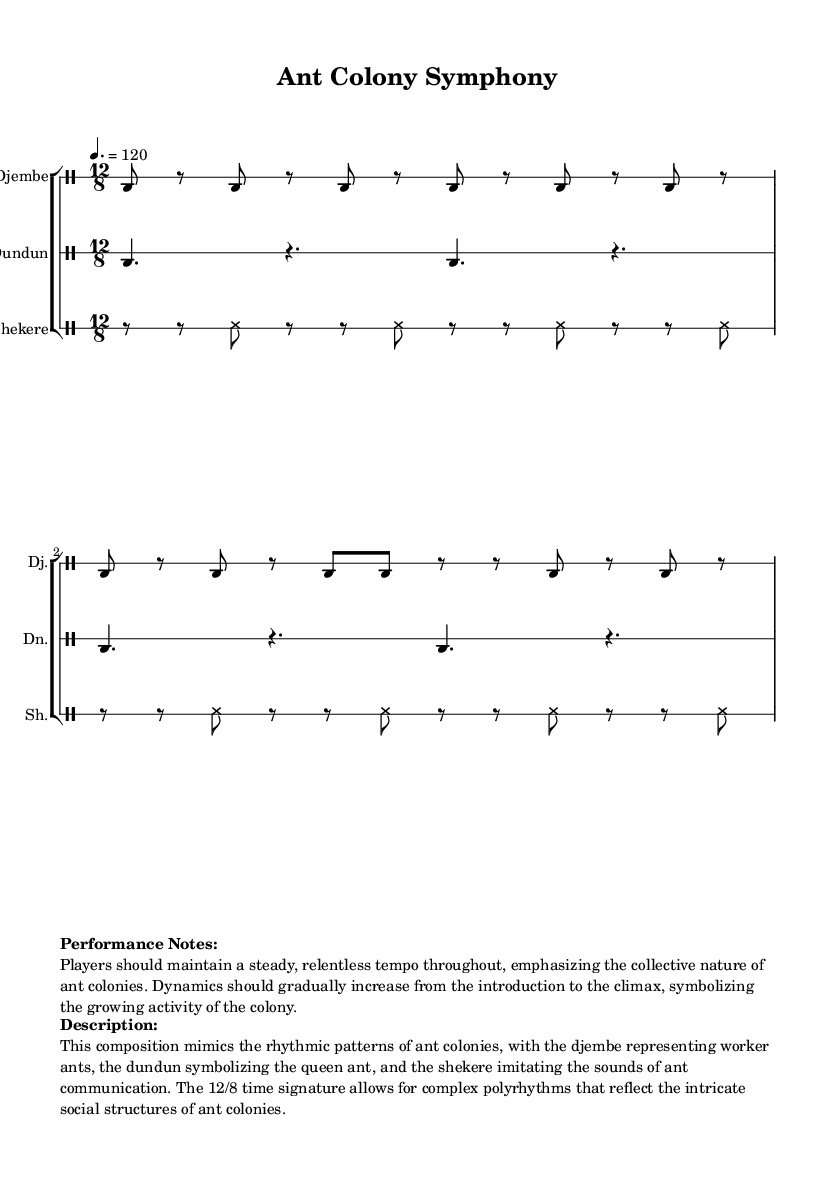What is the key signature of this music? The key signature is written at the beginning of the sheet music and indicates that the piece is in C major, which has no sharps or flats.
Answer: C major What is the time signature of this music? The time signature is found immediately following the key signature and indicates that the piece is in 12/8 time, which suggests it has a compound meter with four beats per measure, each divided into three eighth notes.
Answer: 12/8 What is the tempo marking for this piece? The tempo marking appears at the beginning of the score, indicating a speed of 120 beats per minute, which helps to convey the intended pace of the performance.
Answer: 120 How many instruments are featured in the composition? The score lists three distinct instruments in separate drum staffs: djembe, dundun, and shekere, each contributing to the overall rhythmic texture of the piece.
Answer: Three What rhythmic pattern does the djembe primarily represent? The djembe section features a repeated pattern of bass and rests, symbolizing the relentless and collective effort of worker ants in the colony, reflecting their rhythmic activities.
Answer: Worker ants How does the shekere contribute to the composition's theme? The shekere uses a pattern of shakes and rests, representing the sounds of communication among ants, helping to illustrate the intricate social structures within the colony.
Answer: Ant communication In what way does the dynamics change throughout the piece? The performance notes indicate that dynamics should gradually increase, symbolizing the growing activity and intensity of the ant colony as the piece progresses, emphasizing the collective behavior of the ants.
Answer: Gradually increase 